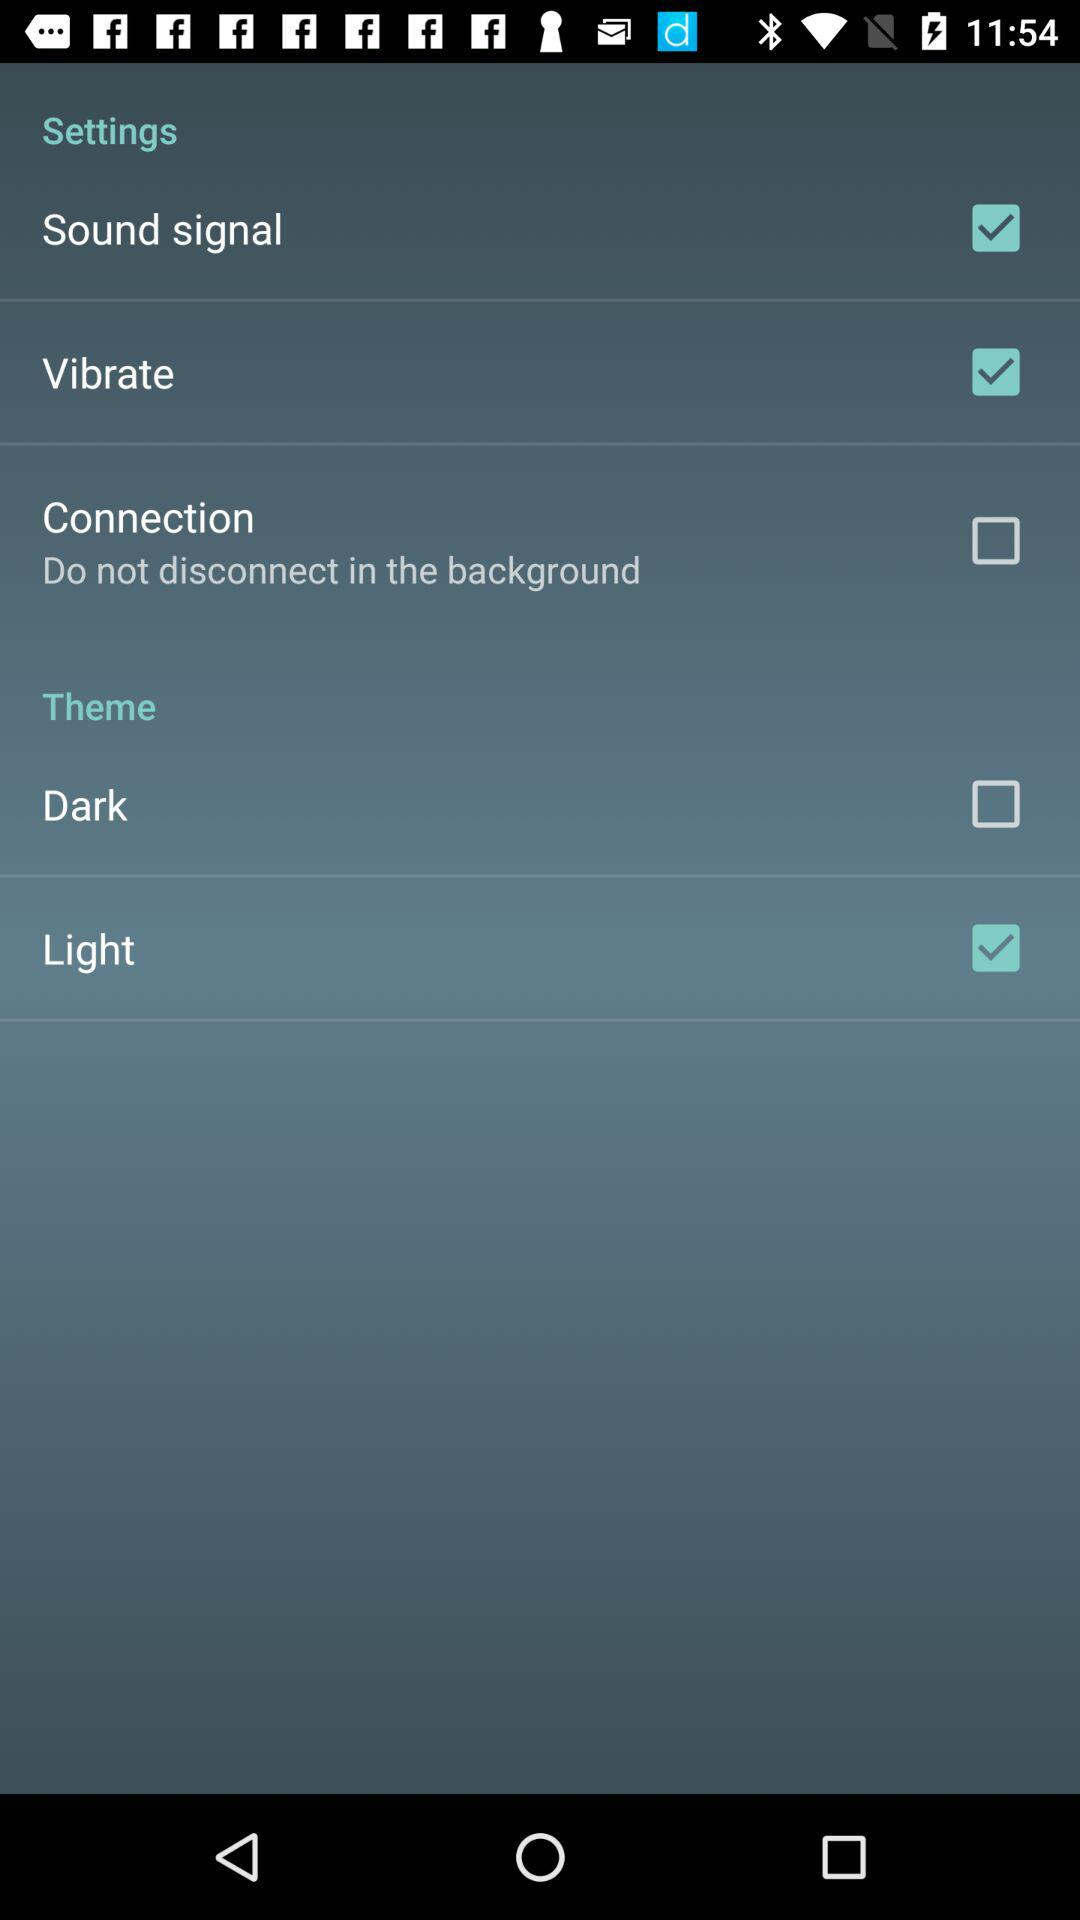What is the status of the "Vibrate" setting? The status is "on". 